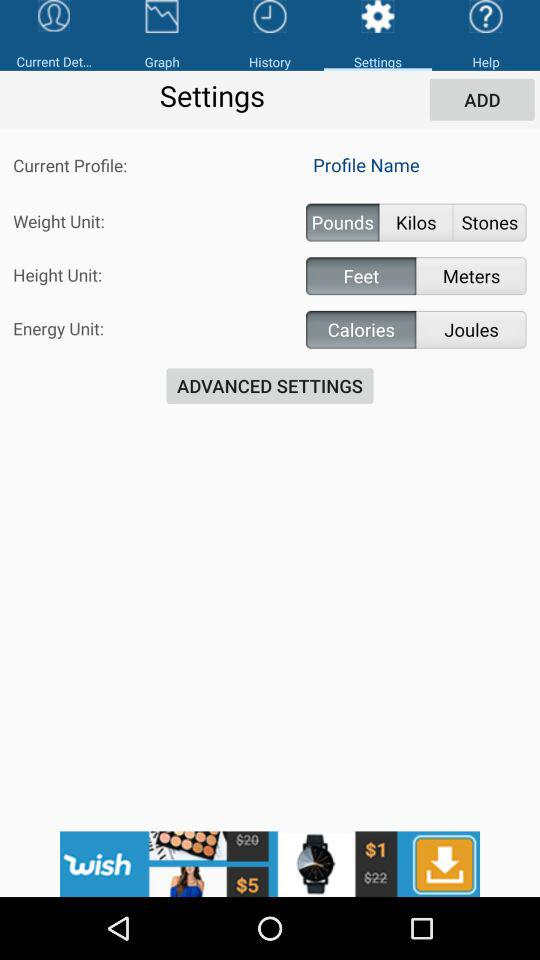How many energy units are available to choose from?
Answer the question using a single word or phrase. 2 